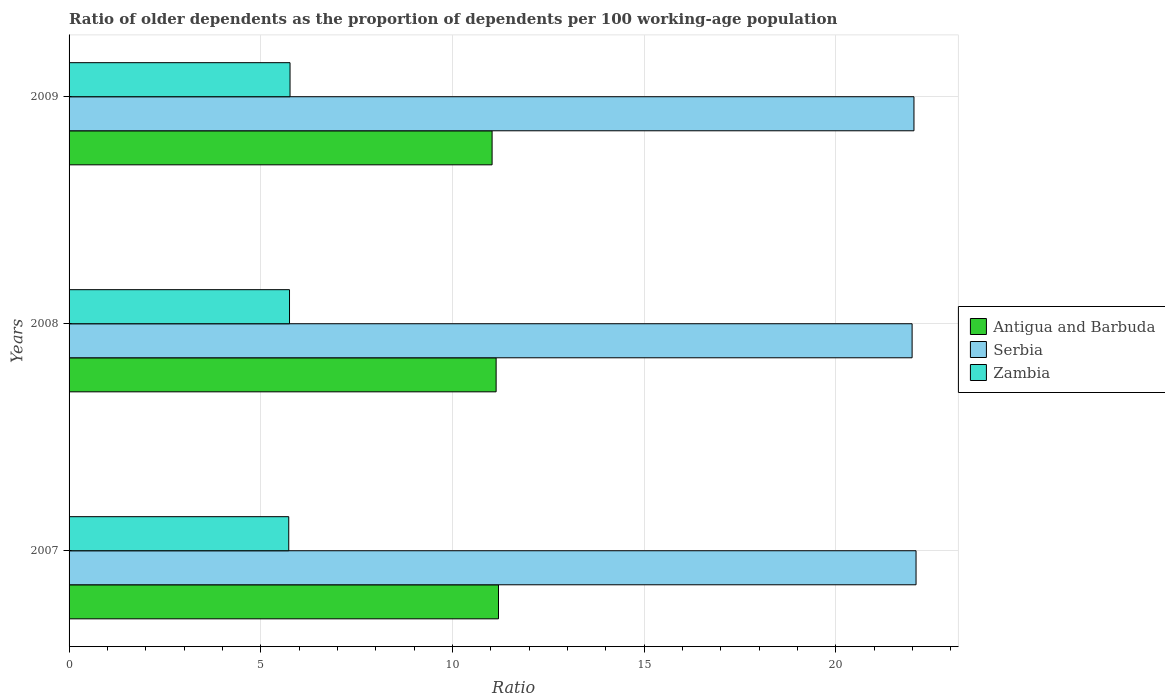How many different coloured bars are there?
Your answer should be compact. 3. How many groups of bars are there?
Offer a very short reply. 3. How many bars are there on the 3rd tick from the top?
Offer a terse response. 3. What is the label of the 3rd group of bars from the top?
Keep it short and to the point. 2007. In how many cases, is the number of bars for a given year not equal to the number of legend labels?
Offer a terse response. 0. What is the age dependency ratio(old) in Antigua and Barbuda in 2007?
Ensure brevity in your answer.  11.2. Across all years, what is the maximum age dependency ratio(old) in Antigua and Barbuda?
Your answer should be compact. 11.2. Across all years, what is the minimum age dependency ratio(old) in Zambia?
Offer a very short reply. 5.73. In which year was the age dependency ratio(old) in Zambia maximum?
Your answer should be very brief. 2009. In which year was the age dependency ratio(old) in Zambia minimum?
Offer a very short reply. 2007. What is the total age dependency ratio(old) in Zambia in the graph?
Provide a short and direct response. 17.24. What is the difference between the age dependency ratio(old) in Serbia in 2008 and that in 2009?
Keep it short and to the point. -0.05. What is the difference between the age dependency ratio(old) in Serbia in 2009 and the age dependency ratio(old) in Zambia in 2008?
Your answer should be very brief. 16.29. What is the average age dependency ratio(old) in Serbia per year?
Offer a terse response. 22.04. In the year 2008, what is the difference between the age dependency ratio(old) in Antigua and Barbuda and age dependency ratio(old) in Zambia?
Offer a very short reply. 5.39. In how many years, is the age dependency ratio(old) in Serbia greater than 1 ?
Provide a succinct answer. 3. What is the ratio of the age dependency ratio(old) in Zambia in 2007 to that in 2009?
Offer a very short reply. 0.99. What is the difference between the highest and the second highest age dependency ratio(old) in Zambia?
Your answer should be compact. 0.01. What is the difference between the highest and the lowest age dependency ratio(old) in Serbia?
Provide a succinct answer. 0.1. In how many years, is the age dependency ratio(old) in Serbia greater than the average age dependency ratio(old) in Serbia taken over all years?
Ensure brevity in your answer.  1. Is the sum of the age dependency ratio(old) in Antigua and Barbuda in 2008 and 2009 greater than the maximum age dependency ratio(old) in Serbia across all years?
Keep it short and to the point. Yes. What does the 2nd bar from the top in 2007 represents?
Keep it short and to the point. Serbia. What does the 3rd bar from the bottom in 2008 represents?
Give a very brief answer. Zambia. Does the graph contain grids?
Your answer should be very brief. Yes. Where does the legend appear in the graph?
Give a very brief answer. Center right. What is the title of the graph?
Give a very brief answer. Ratio of older dependents as the proportion of dependents per 100 working-age population. Does "Malaysia" appear as one of the legend labels in the graph?
Offer a very short reply. No. What is the label or title of the X-axis?
Give a very brief answer. Ratio. What is the label or title of the Y-axis?
Your response must be concise. Years. What is the Ratio of Antigua and Barbuda in 2007?
Make the answer very short. 11.2. What is the Ratio in Serbia in 2007?
Provide a succinct answer. 22.09. What is the Ratio in Zambia in 2007?
Your answer should be very brief. 5.73. What is the Ratio of Antigua and Barbuda in 2008?
Give a very brief answer. 11.14. What is the Ratio of Serbia in 2008?
Offer a very short reply. 21.99. What is the Ratio of Zambia in 2008?
Your answer should be compact. 5.75. What is the Ratio of Antigua and Barbuda in 2009?
Provide a succinct answer. 11.03. What is the Ratio of Serbia in 2009?
Your answer should be very brief. 22.04. What is the Ratio in Zambia in 2009?
Make the answer very short. 5.76. Across all years, what is the maximum Ratio in Antigua and Barbuda?
Ensure brevity in your answer.  11.2. Across all years, what is the maximum Ratio in Serbia?
Your answer should be very brief. 22.09. Across all years, what is the maximum Ratio in Zambia?
Keep it short and to the point. 5.76. Across all years, what is the minimum Ratio in Antigua and Barbuda?
Provide a short and direct response. 11.03. Across all years, what is the minimum Ratio in Serbia?
Your response must be concise. 21.99. Across all years, what is the minimum Ratio in Zambia?
Your answer should be very brief. 5.73. What is the total Ratio in Antigua and Barbuda in the graph?
Your answer should be very brief. 33.37. What is the total Ratio in Serbia in the graph?
Keep it short and to the point. 66.12. What is the total Ratio in Zambia in the graph?
Your answer should be very brief. 17.24. What is the difference between the Ratio in Antigua and Barbuda in 2007 and that in 2008?
Your answer should be very brief. 0.06. What is the difference between the Ratio of Serbia in 2007 and that in 2008?
Ensure brevity in your answer.  0.1. What is the difference between the Ratio of Zambia in 2007 and that in 2008?
Your response must be concise. -0.02. What is the difference between the Ratio in Antigua and Barbuda in 2007 and that in 2009?
Provide a short and direct response. 0.17. What is the difference between the Ratio of Serbia in 2007 and that in 2009?
Ensure brevity in your answer.  0.05. What is the difference between the Ratio in Zambia in 2007 and that in 2009?
Provide a short and direct response. -0.03. What is the difference between the Ratio in Antigua and Barbuda in 2008 and that in 2009?
Keep it short and to the point. 0.11. What is the difference between the Ratio of Serbia in 2008 and that in 2009?
Provide a succinct answer. -0.05. What is the difference between the Ratio of Zambia in 2008 and that in 2009?
Make the answer very short. -0.01. What is the difference between the Ratio in Antigua and Barbuda in 2007 and the Ratio in Serbia in 2008?
Your answer should be very brief. -10.79. What is the difference between the Ratio of Antigua and Barbuda in 2007 and the Ratio of Zambia in 2008?
Keep it short and to the point. 5.45. What is the difference between the Ratio in Serbia in 2007 and the Ratio in Zambia in 2008?
Make the answer very short. 16.34. What is the difference between the Ratio of Antigua and Barbuda in 2007 and the Ratio of Serbia in 2009?
Offer a very short reply. -10.84. What is the difference between the Ratio of Antigua and Barbuda in 2007 and the Ratio of Zambia in 2009?
Your response must be concise. 5.44. What is the difference between the Ratio of Serbia in 2007 and the Ratio of Zambia in 2009?
Offer a very short reply. 16.33. What is the difference between the Ratio in Antigua and Barbuda in 2008 and the Ratio in Serbia in 2009?
Your response must be concise. -10.9. What is the difference between the Ratio of Antigua and Barbuda in 2008 and the Ratio of Zambia in 2009?
Your answer should be very brief. 5.38. What is the difference between the Ratio of Serbia in 2008 and the Ratio of Zambia in 2009?
Your answer should be very brief. 16.23. What is the average Ratio in Antigua and Barbuda per year?
Ensure brevity in your answer.  11.12. What is the average Ratio of Serbia per year?
Offer a terse response. 22.04. What is the average Ratio in Zambia per year?
Give a very brief answer. 5.75. In the year 2007, what is the difference between the Ratio of Antigua and Barbuda and Ratio of Serbia?
Your response must be concise. -10.89. In the year 2007, what is the difference between the Ratio of Antigua and Barbuda and Ratio of Zambia?
Make the answer very short. 5.47. In the year 2007, what is the difference between the Ratio of Serbia and Ratio of Zambia?
Your response must be concise. 16.36. In the year 2008, what is the difference between the Ratio of Antigua and Barbuda and Ratio of Serbia?
Keep it short and to the point. -10.85. In the year 2008, what is the difference between the Ratio in Antigua and Barbuda and Ratio in Zambia?
Keep it short and to the point. 5.39. In the year 2008, what is the difference between the Ratio in Serbia and Ratio in Zambia?
Give a very brief answer. 16.24. In the year 2009, what is the difference between the Ratio of Antigua and Barbuda and Ratio of Serbia?
Your answer should be compact. -11. In the year 2009, what is the difference between the Ratio in Antigua and Barbuda and Ratio in Zambia?
Your answer should be very brief. 5.27. In the year 2009, what is the difference between the Ratio of Serbia and Ratio of Zambia?
Offer a terse response. 16.28. What is the ratio of the Ratio of Antigua and Barbuda in 2007 to that in 2008?
Keep it short and to the point. 1.01. What is the ratio of the Ratio of Serbia in 2007 to that in 2008?
Offer a very short reply. 1. What is the ratio of the Ratio in Antigua and Barbuda in 2007 to that in 2009?
Your answer should be compact. 1.02. What is the ratio of the Ratio of Antigua and Barbuda in 2008 to that in 2009?
Give a very brief answer. 1.01. What is the difference between the highest and the second highest Ratio of Antigua and Barbuda?
Make the answer very short. 0.06. What is the difference between the highest and the second highest Ratio in Serbia?
Your answer should be compact. 0.05. What is the difference between the highest and the second highest Ratio of Zambia?
Your response must be concise. 0.01. What is the difference between the highest and the lowest Ratio in Antigua and Barbuda?
Provide a succinct answer. 0.17. What is the difference between the highest and the lowest Ratio of Serbia?
Ensure brevity in your answer.  0.1. What is the difference between the highest and the lowest Ratio of Zambia?
Ensure brevity in your answer.  0.03. 